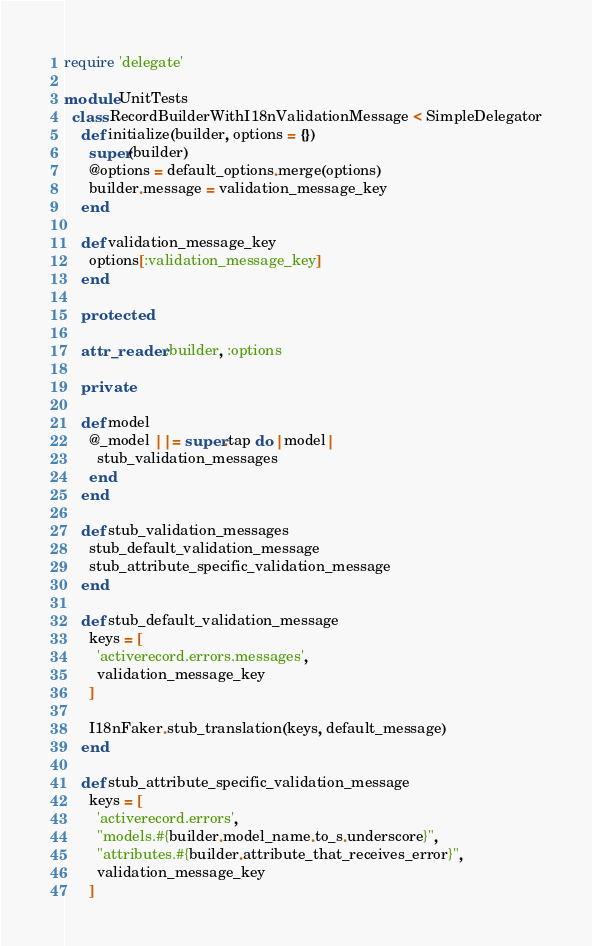<code> <loc_0><loc_0><loc_500><loc_500><_Ruby_>require 'delegate'

module UnitTests
  class RecordBuilderWithI18nValidationMessage < SimpleDelegator
    def initialize(builder, options = {})
      super(builder)
      @options = default_options.merge(options)
      builder.message = validation_message_key
    end

    def validation_message_key
      options[:validation_message_key]
    end

    protected

    attr_reader :builder, :options

    private

    def model
      @_model ||= super.tap do |model|
        stub_validation_messages
      end
    end

    def stub_validation_messages
      stub_default_validation_message
      stub_attribute_specific_validation_message
    end

    def stub_default_validation_message
      keys = [
        'activerecord.errors.messages',
        validation_message_key
      ]

      I18nFaker.stub_translation(keys, default_message)
    end

    def stub_attribute_specific_validation_message
      keys = [
        'activerecord.errors',
        "models.#{builder.model_name.to_s.underscore}",
        "attributes.#{builder.attribute_that_receives_error}",
        validation_message_key
      ]
</code> 